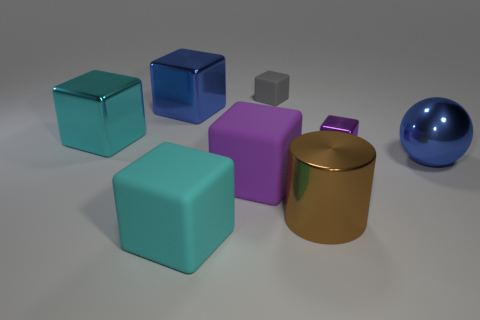There is a brown metal thing that is the same size as the purple rubber cube; what shape is it?
Provide a short and direct response. Cylinder. What number of large objects are in front of the large matte object behind the big brown object?
Make the answer very short. 2. How many other things are there of the same material as the blue ball?
Ensure brevity in your answer.  4. There is a large cyan thing that is behind the big cyan block in front of the big blue ball; what is its shape?
Your response must be concise. Cube. There is a purple cube that is right of the purple rubber cube; what is its size?
Provide a short and direct response. Small. Is the material of the gray object the same as the big cylinder?
Offer a terse response. No. What shape is the large blue object that is made of the same material as the large blue block?
Your answer should be compact. Sphere. Is there any other thing that has the same color as the sphere?
Make the answer very short. Yes. There is a small matte thing that is to the left of the brown shiny object; what is its color?
Your answer should be compact. Gray. There is a matte block that is behind the big ball; is its color the same as the metal sphere?
Ensure brevity in your answer.  No. 